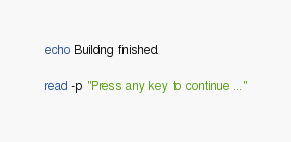Convert code to text. <code><loc_0><loc_0><loc_500><loc_500><_Bash_>echo Building finished.

read -p "Press any key to continue ..."</code> 